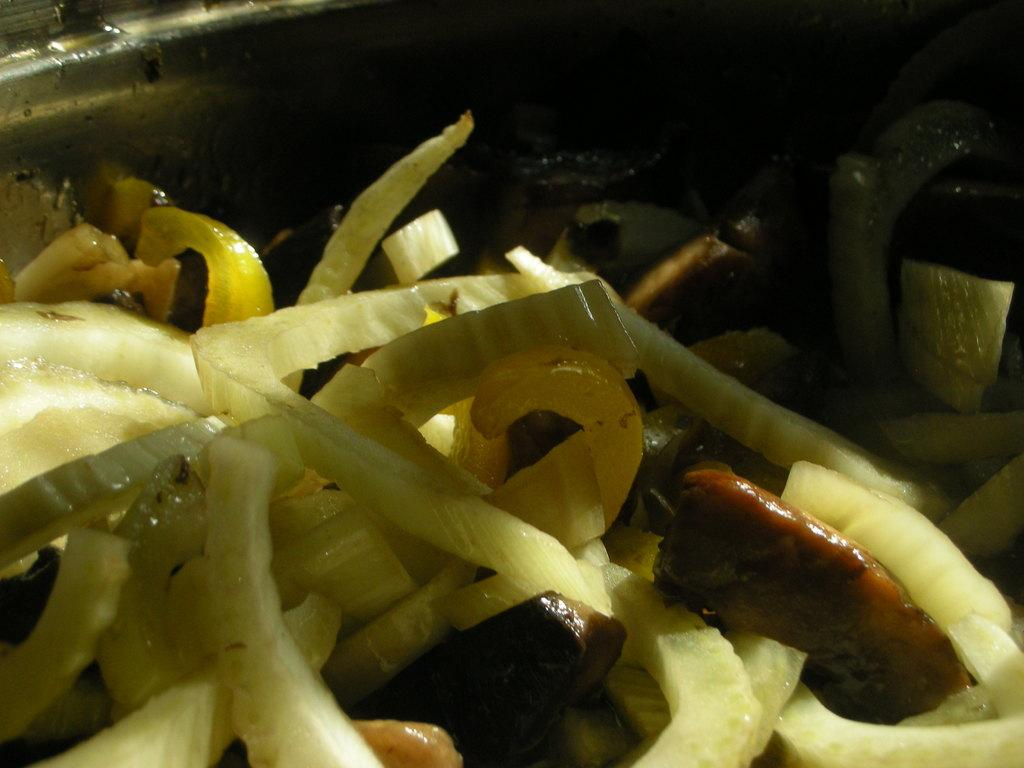What type of food items are present in the image? There are vegetables in the image. What color are the vegetables? The vegetables are yellow in color. What can be seen in the background of the image? The background of the image is dark. Where can you purchase the treatment for the yellow vegetables in the image? There is no treatment mentioned or implied in the image, as it simply features yellow vegetables. 